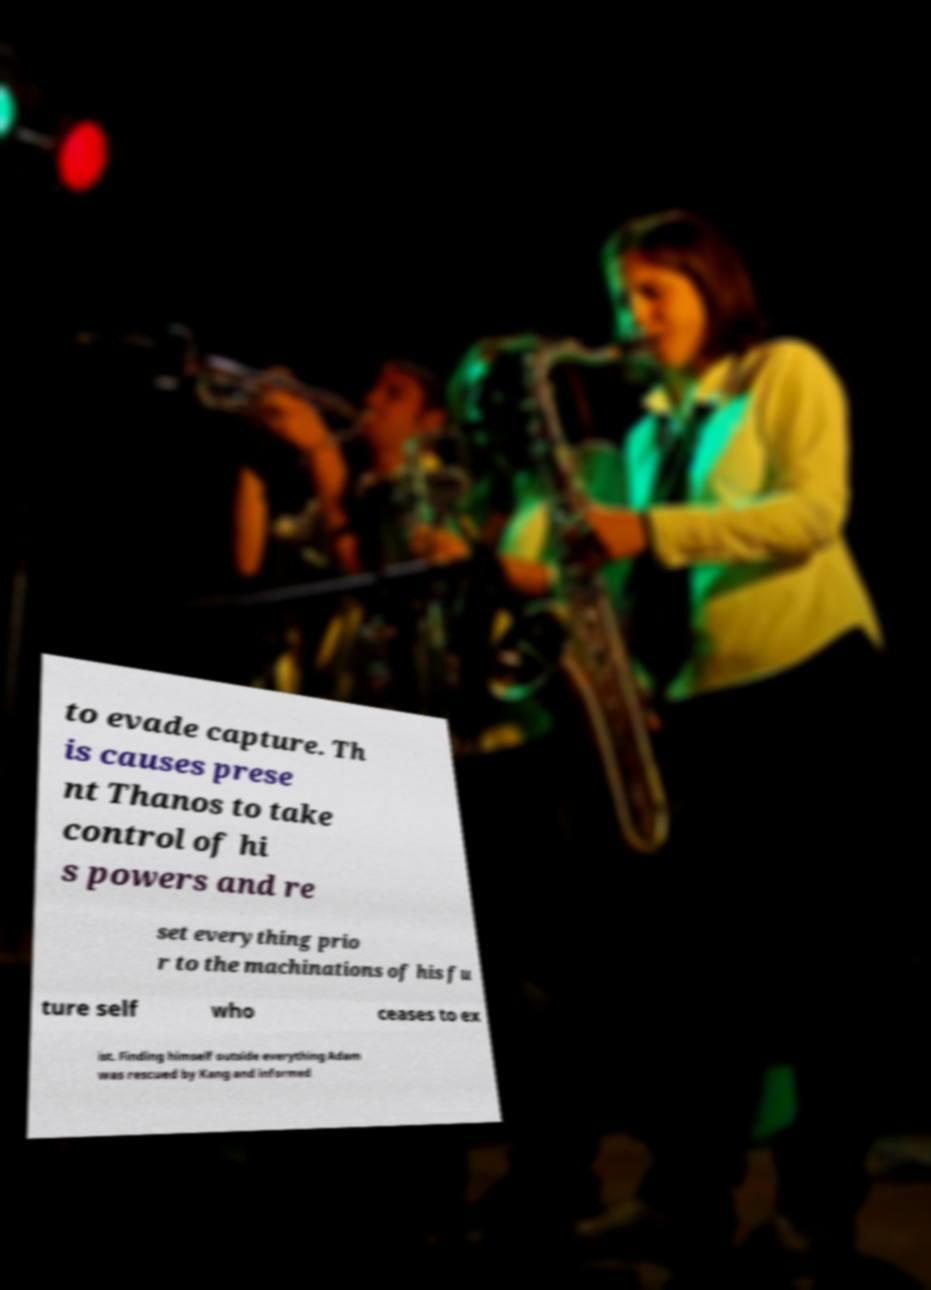Could you extract and type out the text from this image? to evade capture. Th is causes prese nt Thanos to take control of hi s powers and re set everything prio r to the machinations of his fu ture self who ceases to ex ist. Finding himself outside everything Adam was rescued by Kang and informed 